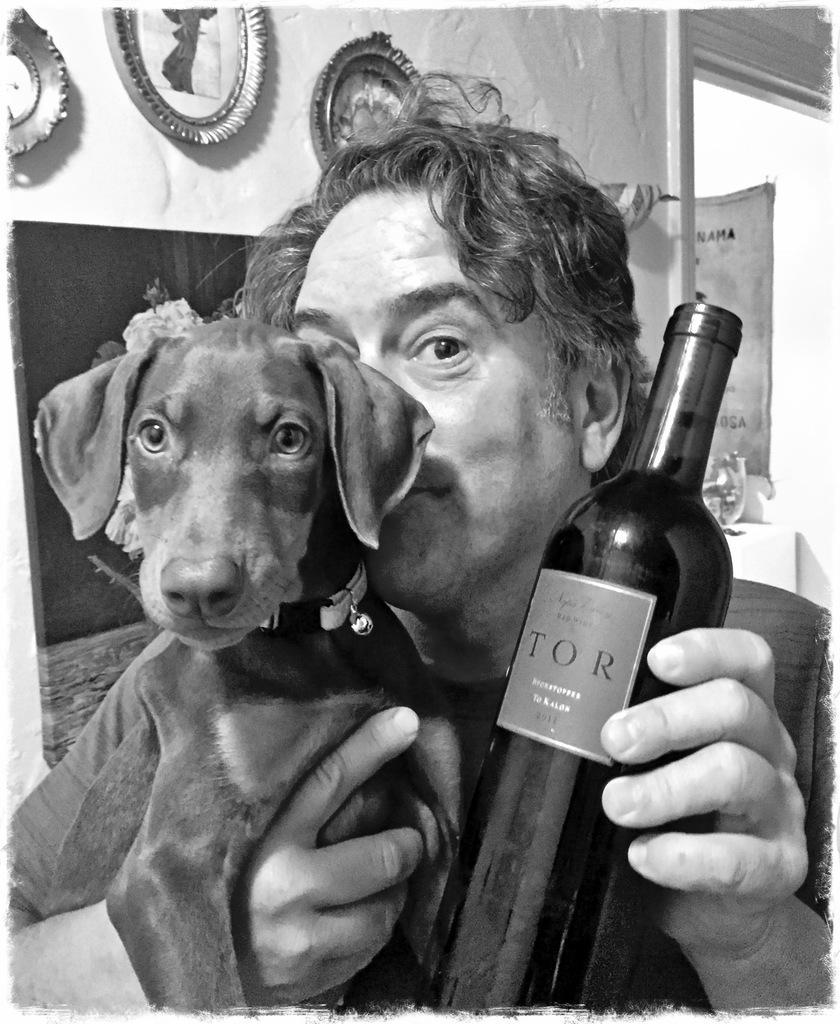Describe this image in one or two sentences. In this image, There is a person holding a wine bottle which is in brown color, There is a dog which is in black color, In the background there is a white color wall on that wall there are some circular objects. 